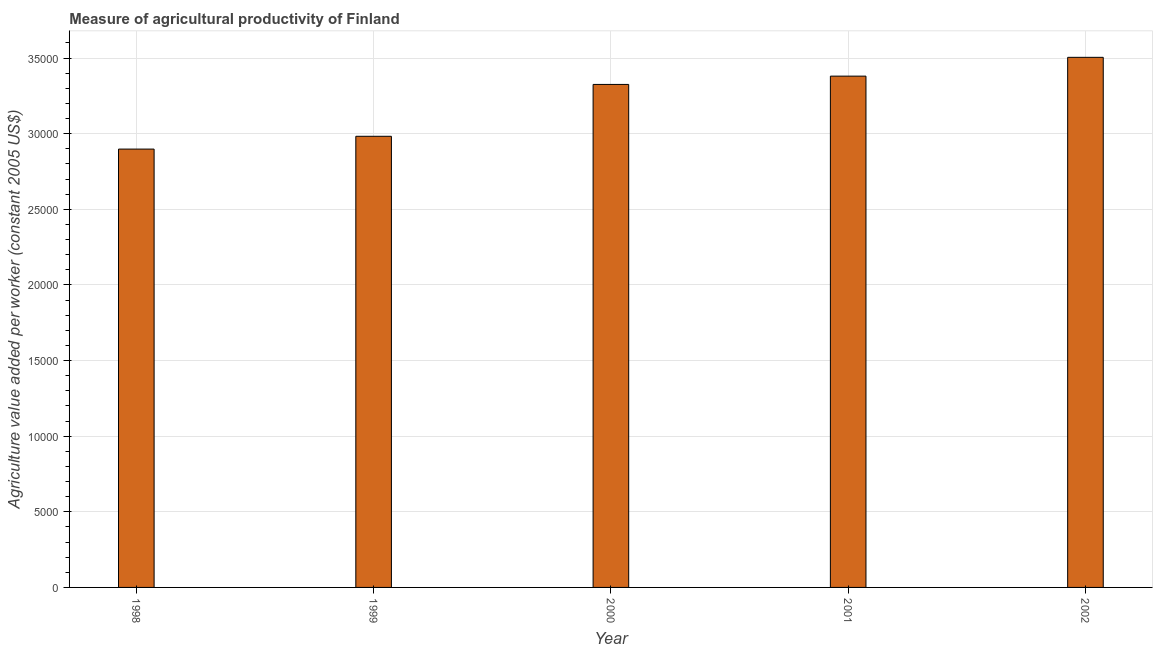Does the graph contain any zero values?
Your answer should be very brief. No. Does the graph contain grids?
Offer a terse response. Yes. What is the title of the graph?
Provide a short and direct response. Measure of agricultural productivity of Finland. What is the label or title of the Y-axis?
Give a very brief answer. Agriculture value added per worker (constant 2005 US$). What is the agriculture value added per worker in 2000?
Provide a succinct answer. 3.33e+04. Across all years, what is the maximum agriculture value added per worker?
Your answer should be compact. 3.50e+04. Across all years, what is the minimum agriculture value added per worker?
Your response must be concise. 2.90e+04. What is the sum of the agriculture value added per worker?
Your answer should be very brief. 1.61e+05. What is the difference between the agriculture value added per worker in 1998 and 2001?
Your response must be concise. -4823.05. What is the average agriculture value added per worker per year?
Give a very brief answer. 3.22e+04. What is the median agriculture value added per worker?
Ensure brevity in your answer.  3.33e+04. In how many years, is the agriculture value added per worker greater than 27000 US$?
Provide a short and direct response. 5. Do a majority of the years between 2002 and 2001 (inclusive) have agriculture value added per worker greater than 8000 US$?
Your answer should be compact. No. What is the ratio of the agriculture value added per worker in 2001 to that in 2002?
Your answer should be very brief. 0.96. Is the agriculture value added per worker in 1998 less than that in 1999?
Ensure brevity in your answer.  Yes. Is the difference between the agriculture value added per worker in 2001 and 2002 greater than the difference between any two years?
Provide a short and direct response. No. What is the difference between the highest and the second highest agriculture value added per worker?
Your response must be concise. 1243.55. Is the sum of the agriculture value added per worker in 2000 and 2001 greater than the maximum agriculture value added per worker across all years?
Give a very brief answer. Yes. What is the difference between the highest and the lowest agriculture value added per worker?
Ensure brevity in your answer.  6066.6. In how many years, is the agriculture value added per worker greater than the average agriculture value added per worker taken over all years?
Offer a very short reply. 3. How many years are there in the graph?
Offer a very short reply. 5. What is the Agriculture value added per worker (constant 2005 US$) in 1998?
Make the answer very short. 2.90e+04. What is the Agriculture value added per worker (constant 2005 US$) in 1999?
Your answer should be very brief. 2.98e+04. What is the Agriculture value added per worker (constant 2005 US$) of 2000?
Your answer should be compact. 3.33e+04. What is the Agriculture value added per worker (constant 2005 US$) of 2001?
Give a very brief answer. 3.38e+04. What is the Agriculture value added per worker (constant 2005 US$) in 2002?
Your response must be concise. 3.50e+04. What is the difference between the Agriculture value added per worker (constant 2005 US$) in 1998 and 1999?
Your answer should be very brief. -846.13. What is the difference between the Agriculture value added per worker (constant 2005 US$) in 1998 and 2000?
Your answer should be compact. -4274.95. What is the difference between the Agriculture value added per worker (constant 2005 US$) in 1998 and 2001?
Offer a very short reply. -4823.05. What is the difference between the Agriculture value added per worker (constant 2005 US$) in 1998 and 2002?
Your answer should be very brief. -6066.6. What is the difference between the Agriculture value added per worker (constant 2005 US$) in 1999 and 2000?
Provide a succinct answer. -3428.82. What is the difference between the Agriculture value added per worker (constant 2005 US$) in 1999 and 2001?
Provide a succinct answer. -3976.92. What is the difference between the Agriculture value added per worker (constant 2005 US$) in 1999 and 2002?
Your answer should be very brief. -5220.47. What is the difference between the Agriculture value added per worker (constant 2005 US$) in 2000 and 2001?
Your answer should be compact. -548.1. What is the difference between the Agriculture value added per worker (constant 2005 US$) in 2000 and 2002?
Provide a succinct answer. -1791.65. What is the difference between the Agriculture value added per worker (constant 2005 US$) in 2001 and 2002?
Make the answer very short. -1243.55. What is the ratio of the Agriculture value added per worker (constant 2005 US$) in 1998 to that in 2000?
Give a very brief answer. 0.87. What is the ratio of the Agriculture value added per worker (constant 2005 US$) in 1998 to that in 2001?
Offer a terse response. 0.86. What is the ratio of the Agriculture value added per worker (constant 2005 US$) in 1998 to that in 2002?
Your answer should be compact. 0.83. What is the ratio of the Agriculture value added per worker (constant 2005 US$) in 1999 to that in 2000?
Offer a very short reply. 0.9. What is the ratio of the Agriculture value added per worker (constant 2005 US$) in 1999 to that in 2001?
Provide a short and direct response. 0.88. What is the ratio of the Agriculture value added per worker (constant 2005 US$) in 1999 to that in 2002?
Give a very brief answer. 0.85. What is the ratio of the Agriculture value added per worker (constant 2005 US$) in 2000 to that in 2002?
Your response must be concise. 0.95. What is the ratio of the Agriculture value added per worker (constant 2005 US$) in 2001 to that in 2002?
Provide a succinct answer. 0.96. 